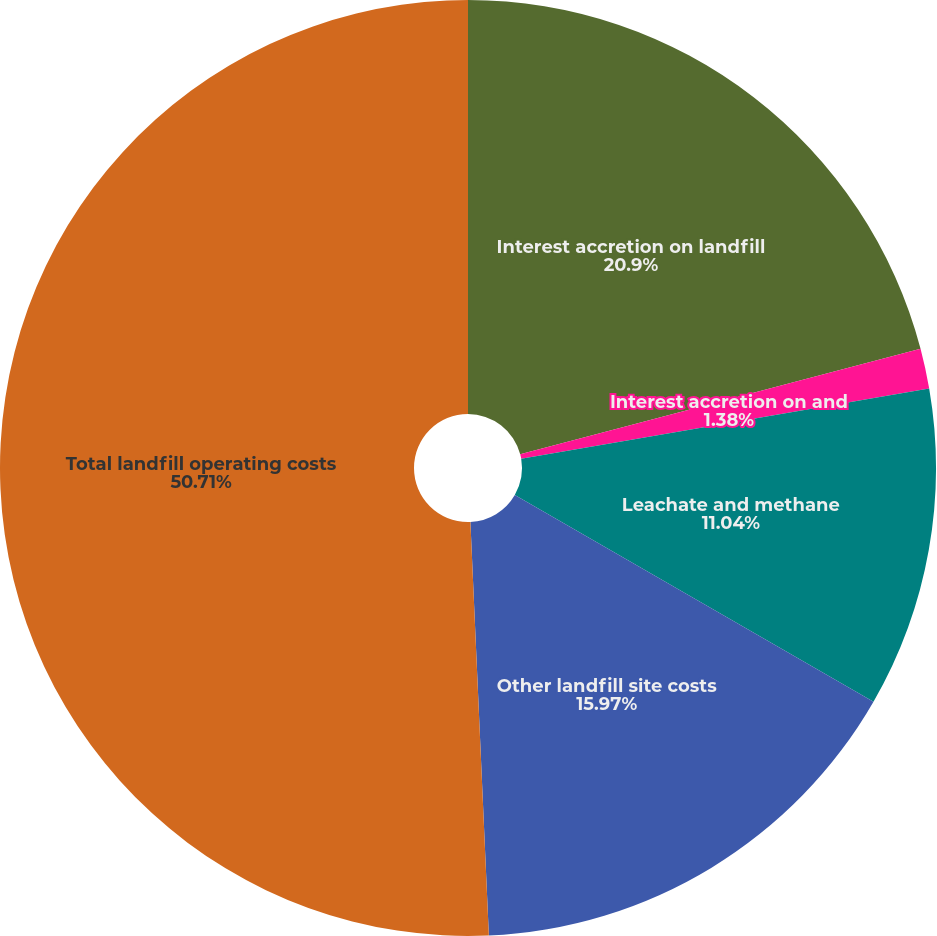Convert chart to OTSL. <chart><loc_0><loc_0><loc_500><loc_500><pie_chart><fcel>Interest accretion on landfill<fcel>Interest accretion on and<fcel>Leachate and methane<fcel>Other landfill site costs<fcel>Total landfill operating costs<nl><fcel>20.9%<fcel>1.38%<fcel>11.04%<fcel>15.97%<fcel>50.71%<nl></chart> 